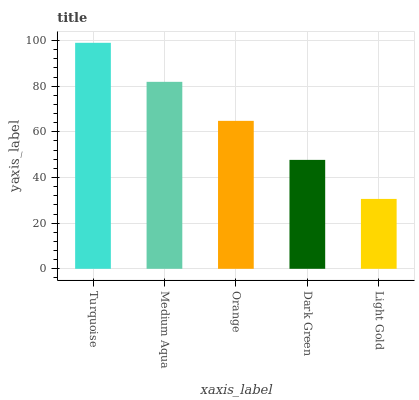Is Light Gold the minimum?
Answer yes or no. Yes. Is Turquoise the maximum?
Answer yes or no. Yes. Is Medium Aqua the minimum?
Answer yes or no. No. Is Medium Aqua the maximum?
Answer yes or no. No. Is Turquoise greater than Medium Aqua?
Answer yes or no. Yes. Is Medium Aqua less than Turquoise?
Answer yes or no. Yes. Is Medium Aqua greater than Turquoise?
Answer yes or no. No. Is Turquoise less than Medium Aqua?
Answer yes or no. No. Is Orange the high median?
Answer yes or no. Yes. Is Orange the low median?
Answer yes or no. Yes. Is Turquoise the high median?
Answer yes or no. No. Is Medium Aqua the low median?
Answer yes or no. No. 